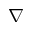<formula> <loc_0><loc_0><loc_500><loc_500>{ \nabla }</formula> 